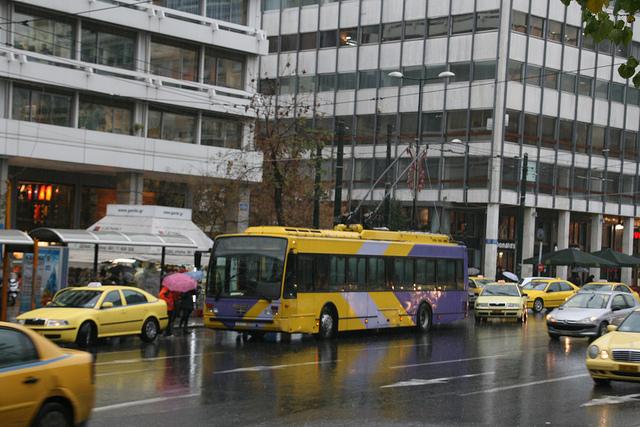What color is the bus?
Keep it brief. Yellow and purple. Is the bus one solid color?
Quick response, please. No. What country is it?
Concise answer only. United states. 